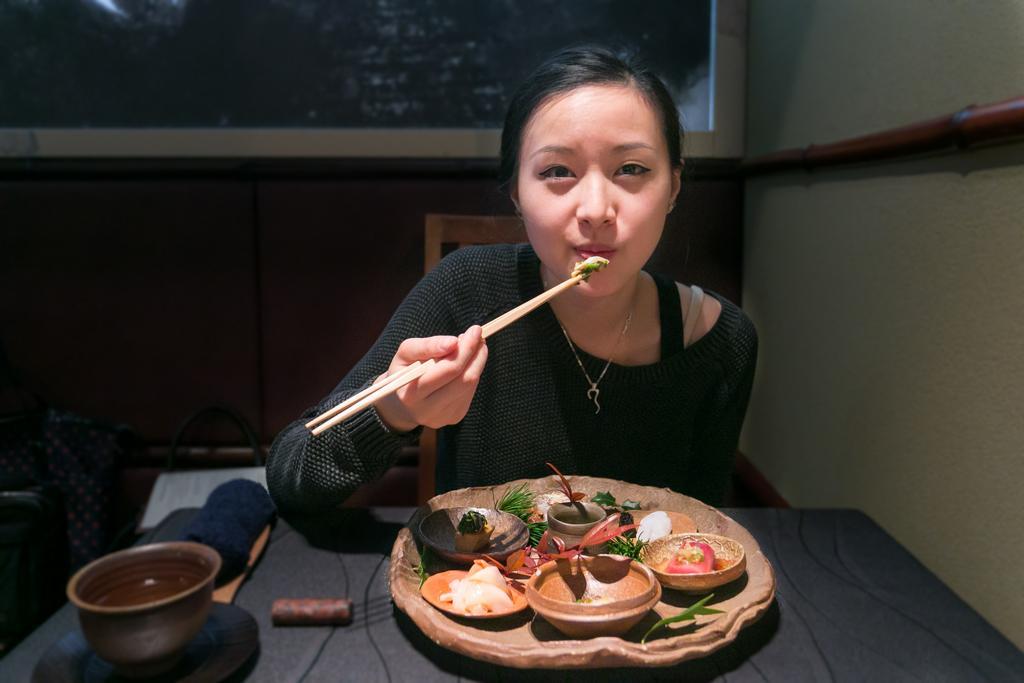How would you summarize this image in a sentence or two? In this image, There is a table which is covered by a black cloth on that there is a plate and in that there are some food items and in the middle there is a woman who is holding some food and on the table there is a cup of water, In the background there is a wall of brown color,in the right side there is a wall of white color. 